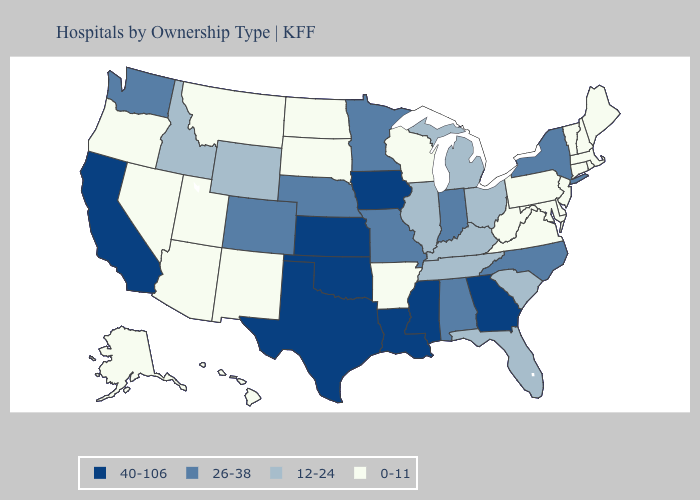Does Tennessee have the lowest value in the South?
Be succinct. No. Which states have the lowest value in the USA?
Short answer required. Alaska, Arizona, Arkansas, Connecticut, Delaware, Hawaii, Maine, Maryland, Massachusetts, Montana, Nevada, New Hampshire, New Jersey, New Mexico, North Dakota, Oregon, Pennsylvania, Rhode Island, South Dakota, Utah, Vermont, Virginia, West Virginia, Wisconsin. Which states have the highest value in the USA?
Be succinct. California, Georgia, Iowa, Kansas, Louisiana, Mississippi, Oklahoma, Texas. Among the states that border Montana , which have the lowest value?
Short answer required. North Dakota, South Dakota. What is the highest value in states that border North Dakota?
Quick response, please. 26-38. Does Arkansas have the lowest value in the USA?
Answer briefly. Yes. Does California have the lowest value in the West?
Write a very short answer. No. Does Utah have a higher value than Maryland?
Answer briefly. No. Which states have the lowest value in the USA?
Give a very brief answer. Alaska, Arizona, Arkansas, Connecticut, Delaware, Hawaii, Maine, Maryland, Massachusetts, Montana, Nevada, New Hampshire, New Jersey, New Mexico, North Dakota, Oregon, Pennsylvania, Rhode Island, South Dakota, Utah, Vermont, Virginia, West Virginia, Wisconsin. What is the value of Washington?
Concise answer only. 26-38. Name the states that have a value in the range 26-38?
Concise answer only. Alabama, Colorado, Indiana, Minnesota, Missouri, Nebraska, New York, North Carolina, Washington. What is the value of Virginia?
Short answer required. 0-11. What is the highest value in the West ?
Concise answer only. 40-106. Is the legend a continuous bar?
Keep it brief. No. Does Maine have the lowest value in the USA?
Quick response, please. Yes. 